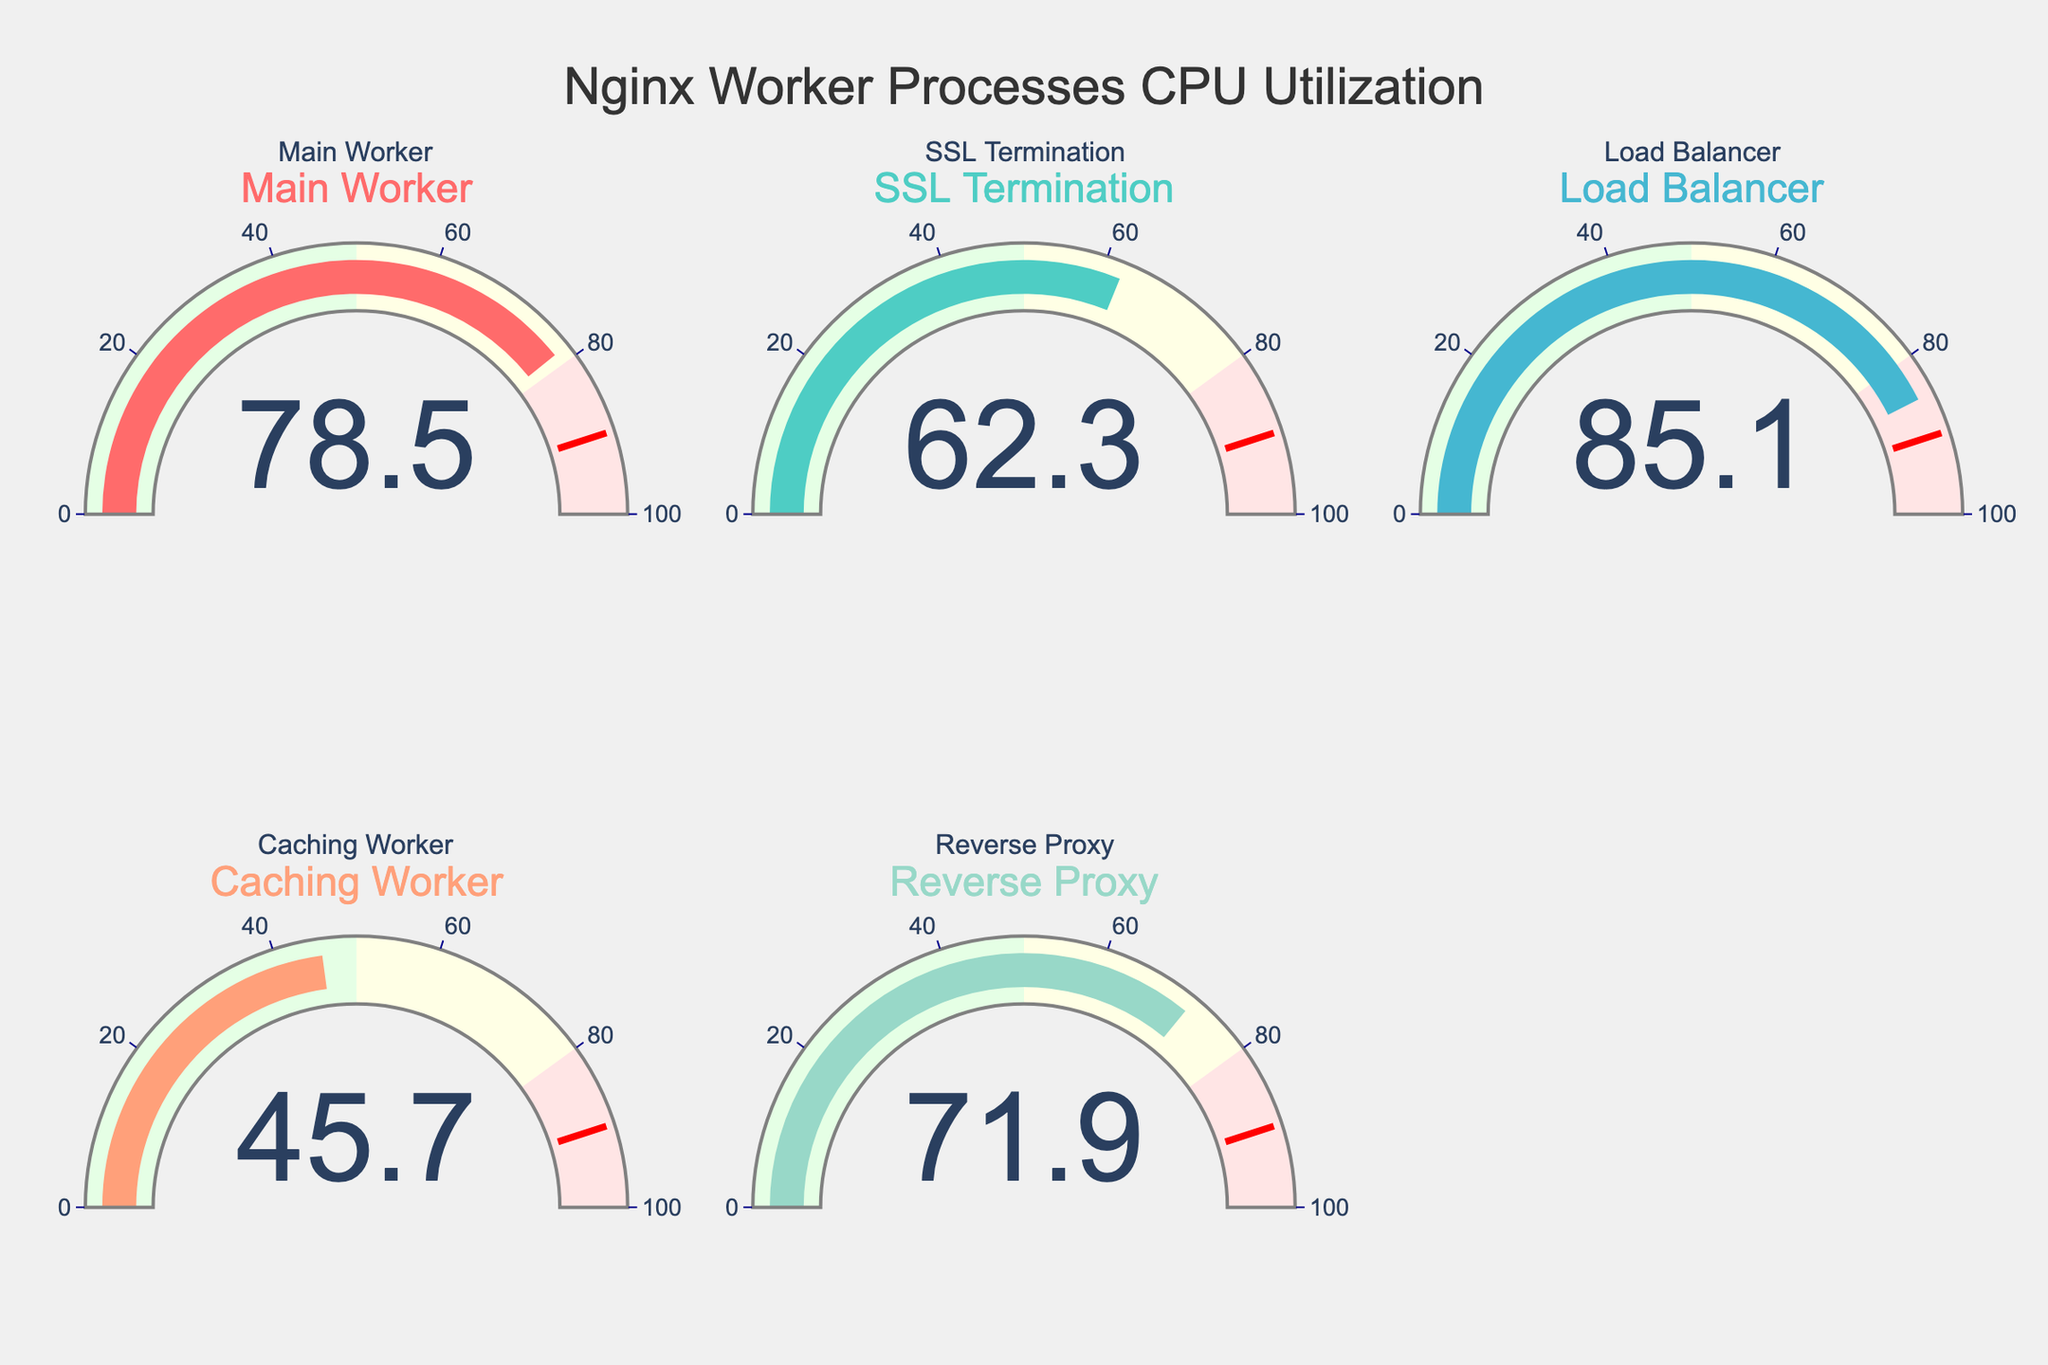What's the title of the figure? The title is displayed at the top center of the figure and reads "Nginx Worker Processes CPU Utilization".
Answer: Nginx Worker Processes CPU Utilization Which worker process has the highest CPU utilization? By observing the gauge charts, the worker process with the highest value is "Load Balancer" with a CPU utilization of 85.1%.
Answer: Load Balancer What is the average CPU utilization of all worker processes? Add all the CPU utilization percentages and divide by the number of worker processes: (78.5 + 62.3 + 85.1 + 45.7 + 71.9) / 5 = 343.5 / 5 = 68.7%
Answer: 68.7% Which worker process has a CPU utilization percentage closest to 50%? The "Caching Worker" has a CPU utilization of 45.7%, which is the closest to 50% among all processes.
Answer: Caching Worker How many worker processes have a CPU utilization above 70%? Count the gauge charts with values above 70%: "Main Worker" (78.5%), "Load Balancer" (85.1%), and "Reverse Proxy" (71.9%) make it three worker processes.
Answer: 3 What color is used for the gauge indicator of the "Main Worker" process? The gauge with the title "Main Worker" uses a color that can be identified as a shade of red.
Answer: Red What is the difference in CPU utilization between the "Main Worker" and the "Caching Worker"? Subtract the CPU utilization of the "Caching Worker" from the "Main Worker": 78.5% - 45.7% = 32.8%
Answer: 32.8% Which worker process has the lowest CPU utilization? The "Caching Worker" has a CPU utilization of 45.7%, the lowest among all worker processes.
Answer: Caching Worker What range is indicated by the red-colored step in each gauge? The red-colored step in each gauge indicates the range from 80% to 100%.
Answer: 80-100% Does the "SSL Termination" worker process exceed the threshold value of 90%? The gauge chart for "SSL Termination" shows a CPU utilization of 62.3%, which is below the threshold value of 90%.
Answer: No 